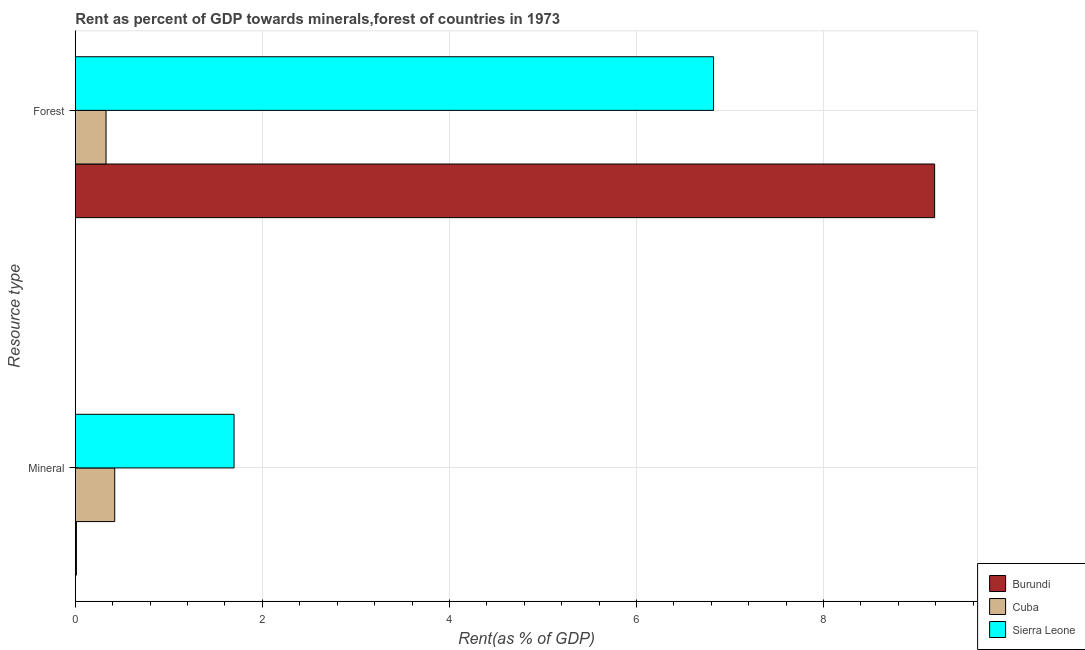Are the number of bars on each tick of the Y-axis equal?
Give a very brief answer. Yes. How many bars are there on the 1st tick from the top?
Your response must be concise. 3. How many bars are there on the 2nd tick from the bottom?
Offer a terse response. 3. What is the label of the 2nd group of bars from the top?
Your response must be concise. Mineral. What is the forest rent in Burundi?
Ensure brevity in your answer.  9.19. Across all countries, what is the maximum mineral rent?
Make the answer very short. 1.7. Across all countries, what is the minimum mineral rent?
Provide a short and direct response. 0.01. In which country was the mineral rent maximum?
Make the answer very short. Sierra Leone. In which country was the mineral rent minimum?
Keep it short and to the point. Burundi. What is the total forest rent in the graph?
Ensure brevity in your answer.  16.34. What is the difference between the mineral rent in Cuba and that in Sierra Leone?
Your answer should be very brief. -1.28. What is the difference between the forest rent in Cuba and the mineral rent in Sierra Leone?
Offer a very short reply. -1.37. What is the average mineral rent per country?
Ensure brevity in your answer.  0.71. What is the difference between the forest rent and mineral rent in Sierra Leone?
Keep it short and to the point. 5.13. What is the ratio of the mineral rent in Sierra Leone to that in Cuba?
Your response must be concise. 4.03. What does the 2nd bar from the top in Forest represents?
Provide a succinct answer. Cuba. What does the 3rd bar from the bottom in Forest represents?
Your answer should be compact. Sierra Leone. Are the values on the major ticks of X-axis written in scientific E-notation?
Offer a very short reply. No. Does the graph contain any zero values?
Your answer should be very brief. No. How are the legend labels stacked?
Offer a terse response. Vertical. What is the title of the graph?
Make the answer very short. Rent as percent of GDP towards minerals,forest of countries in 1973. What is the label or title of the X-axis?
Offer a very short reply. Rent(as % of GDP). What is the label or title of the Y-axis?
Your answer should be very brief. Resource type. What is the Rent(as % of GDP) of Burundi in Mineral?
Provide a succinct answer. 0.01. What is the Rent(as % of GDP) in Cuba in Mineral?
Your answer should be compact. 0.42. What is the Rent(as % of GDP) of Sierra Leone in Mineral?
Give a very brief answer. 1.7. What is the Rent(as % of GDP) of Burundi in Forest?
Your answer should be compact. 9.19. What is the Rent(as % of GDP) in Cuba in Forest?
Provide a short and direct response. 0.33. What is the Rent(as % of GDP) in Sierra Leone in Forest?
Offer a terse response. 6.82. Across all Resource type, what is the maximum Rent(as % of GDP) in Burundi?
Give a very brief answer. 9.19. Across all Resource type, what is the maximum Rent(as % of GDP) in Cuba?
Give a very brief answer. 0.42. Across all Resource type, what is the maximum Rent(as % of GDP) of Sierra Leone?
Your answer should be very brief. 6.82. Across all Resource type, what is the minimum Rent(as % of GDP) of Burundi?
Offer a terse response. 0.01. Across all Resource type, what is the minimum Rent(as % of GDP) in Cuba?
Make the answer very short. 0.33. Across all Resource type, what is the minimum Rent(as % of GDP) of Sierra Leone?
Offer a very short reply. 1.7. What is the total Rent(as % of GDP) in Burundi in the graph?
Keep it short and to the point. 9.2. What is the total Rent(as % of GDP) in Cuba in the graph?
Give a very brief answer. 0.75. What is the total Rent(as % of GDP) of Sierra Leone in the graph?
Ensure brevity in your answer.  8.52. What is the difference between the Rent(as % of GDP) of Burundi in Mineral and that in Forest?
Offer a terse response. -9.18. What is the difference between the Rent(as % of GDP) in Cuba in Mineral and that in Forest?
Your response must be concise. 0.09. What is the difference between the Rent(as % of GDP) in Sierra Leone in Mineral and that in Forest?
Your answer should be very brief. -5.13. What is the difference between the Rent(as % of GDP) of Burundi in Mineral and the Rent(as % of GDP) of Cuba in Forest?
Ensure brevity in your answer.  -0.32. What is the difference between the Rent(as % of GDP) of Burundi in Mineral and the Rent(as % of GDP) of Sierra Leone in Forest?
Provide a short and direct response. -6.81. What is the difference between the Rent(as % of GDP) of Cuba in Mineral and the Rent(as % of GDP) of Sierra Leone in Forest?
Your answer should be very brief. -6.4. What is the average Rent(as % of GDP) of Burundi per Resource type?
Give a very brief answer. 4.6. What is the average Rent(as % of GDP) in Cuba per Resource type?
Offer a very short reply. 0.38. What is the average Rent(as % of GDP) of Sierra Leone per Resource type?
Offer a terse response. 4.26. What is the difference between the Rent(as % of GDP) of Burundi and Rent(as % of GDP) of Cuba in Mineral?
Make the answer very short. -0.41. What is the difference between the Rent(as % of GDP) in Burundi and Rent(as % of GDP) in Sierra Leone in Mineral?
Your answer should be compact. -1.69. What is the difference between the Rent(as % of GDP) in Cuba and Rent(as % of GDP) in Sierra Leone in Mineral?
Ensure brevity in your answer.  -1.28. What is the difference between the Rent(as % of GDP) in Burundi and Rent(as % of GDP) in Cuba in Forest?
Offer a terse response. 8.86. What is the difference between the Rent(as % of GDP) in Burundi and Rent(as % of GDP) in Sierra Leone in Forest?
Provide a succinct answer. 2.36. What is the difference between the Rent(as % of GDP) in Cuba and Rent(as % of GDP) in Sierra Leone in Forest?
Ensure brevity in your answer.  -6.5. What is the ratio of the Rent(as % of GDP) in Burundi in Mineral to that in Forest?
Your answer should be compact. 0. What is the ratio of the Rent(as % of GDP) of Cuba in Mineral to that in Forest?
Ensure brevity in your answer.  1.28. What is the ratio of the Rent(as % of GDP) in Sierra Leone in Mineral to that in Forest?
Provide a succinct answer. 0.25. What is the difference between the highest and the second highest Rent(as % of GDP) in Burundi?
Give a very brief answer. 9.18. What is the difference between the highest and the second highest Rent(as % of GDP) of Cuba?
Your response must be concise. 0.09. What is the difference between the highest and the second highest Rent(as % of GDP) in Sierra Leone?
Ensure brevity in your answer.  5.13. What is the difference between the highest and the lowest Rent(as % of GDP) in Burundi?
Provide a short and direct response. 9.18. What is the difference between the highest and the lowest Rent(as % of GDP) in Cuba?
Offer a terse response. 0.09. What is the difference between the highest and the lowest Rent(as % of GDP) of Sierra Leone?
Give a very brief answer. 5.13. 